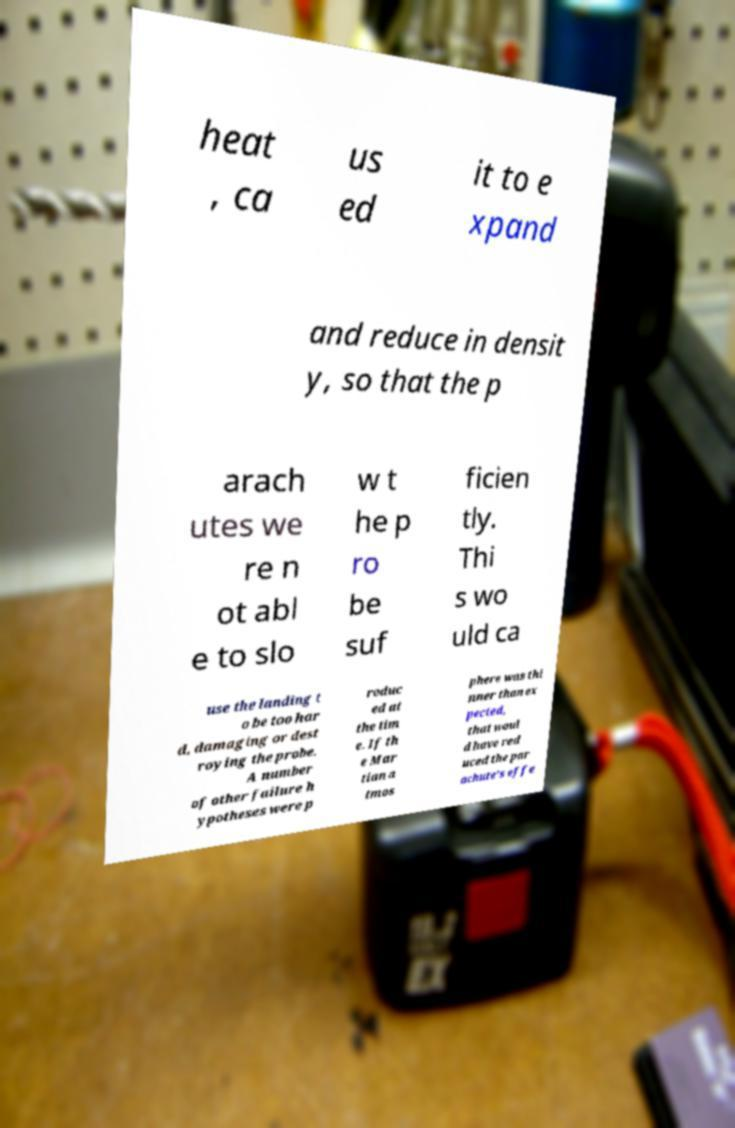For documentation purposes, I need the text within this image transcribed. Could you provide that? heat , ca us ed it to e xpand and reduce in densit y, so that the p arach utes we re n ot abl e to slo w t he p ro be suf ficien tly. Thi s wo uld ca use the landing t o be too har d, damaging or dest roying the probe. A number of other failure h ypotheses were p roduc ed at the tim e. If th e Mar tian a tmos phere was thi nner than ex pected, that woul d have red uced the par achute's effe 